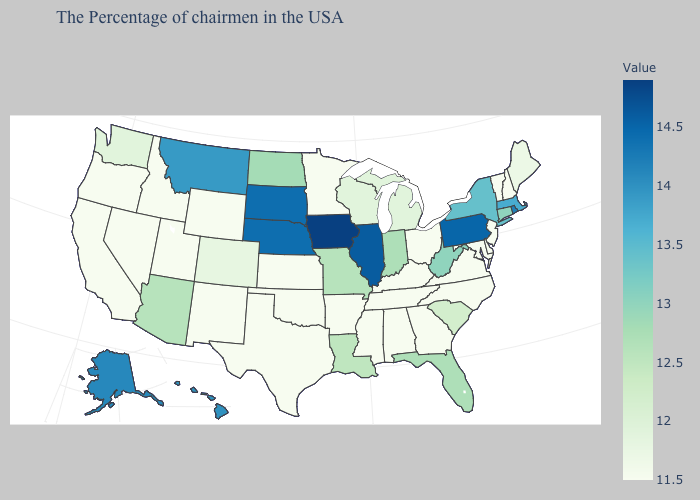Does Hawaii have the lowest value in the West?
Quick response, please. No. Which states have the lowest value in the West?
Write a very short answer. Wyoming, New Mexico, Utah, Idaho, Nevada, California, Oregon. Does New Hampshire have the highest value in the USA?
Be succinct. No. Which states hav the highest value in the MidWest?
Give a very brief answer. Iowa. 